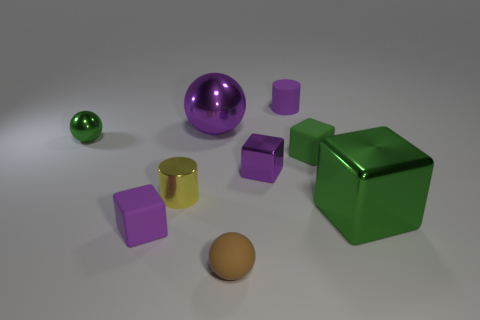How many other objects are the same shape as the green rubber object?
Keep it short and to the point. 3. There is a small shiny cylinder; what number of cubes are in front of it?
Your response must be concise. 2. Is the number of large green metallic cubes that are behind the tiny purple cylinder less than the number of shiny blocks on the left side of the yellow cylinder?
Make the answer very short. No. There is a small rubber thing behind the tiny sphere that is behind the matte object that is on the right side of the small matte cylinder; what is its shape?
Your answer should be compact. Cylinder. What is the shape of the metallic thing that is right of the big purple metallic ball and on the left side of the large green shiny object?
Offer a terse response. Cube. Is there a big purple ball made of the same material as the large purple thing?
Provide a succinct answer. No. There is a sphere that is the same color as the small metal cube; what is its size?
Your response must be concise. Large. There is a matte block that is behind the tiny purple rubber block; what color is it?
Provide a short and direct response. Green. Is the shape of the tiny brown rubber object the same as the rubber thing that is behind the purple ball?
Offer a terse response. No. Is there a shiny cube that has the same color as the large metal ball?
Make the answer very short. Yes. 